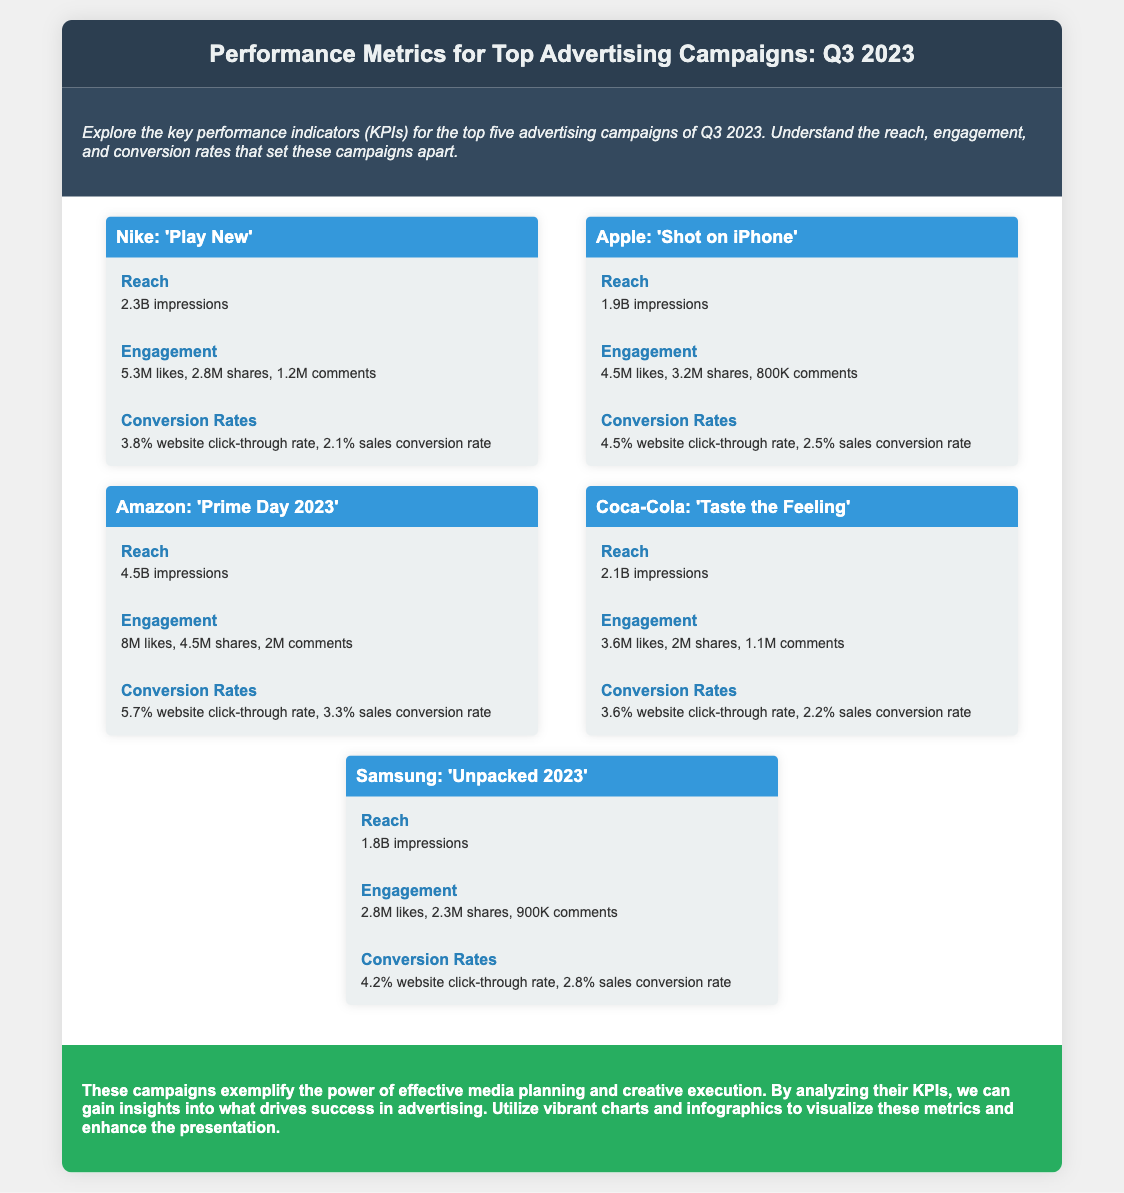What is the reach of Nike's campaign? The reach is the total impressions for the Nike campaign, which is 2.3 billion.
Answer: 2.3B impressions What were the engagement numbers for Amazon's 'Prime Day 2023'? The engagement numbers include likes, shares, and comments for the Amazon campaign, which are 8 million likes, 4.5 million shares, and 2 million comments.
Answer: 8M likes, 4.5M shares, 2M comments Which campaign had the highest conversion rate? The campaign's conversion rates are compared, and the one with the highest sales conversion rate is identified, which is Amazon's 'Prime Day 2023' at 3.3%.
Answer: 3.3% How many campaigns are featured in the document? The document lists a total of five advertising campaigns analyzed for their performance metrics.
Answer: 5 What is the engagement for Apple’s campaign? The engagement for Apple’s campaign is presented with the figures for likes, shares, and comments, which are 4.5 million likes, 3.2 million shares, and 800,000 comments.
Answer: 4.5M likes, 3.2M shares, 800K comments Which campaign had a reach of 1.8 billion impressions? The document states that Samsung's 'Unpacked 2023' campaign had a reach of 1.8 billion impressions.
Answer: Samsung: 'Unpacked 2023' What is the primary focus of the document? The document aims to explore key performance indicators (KPIs) of top advertising campaigns from the last quarter, specifically analyzing reach, engagement, and conversion rates.
Answer: Performance Metrics for Top Advertising Campaigns Which company had a lower engagement: Coca-Cola or Samsung? The engagement figures for Coca-Cola's campaign show 3.6 million likes, while Samsung's campaign shows 2.8 million likes, thus indicating which had lower engagement.
Answer: Samsung What is included in the conclusion of the document? The conclusion summarizes the effectiveness of media planning and execution and encourages the visualization of KPIs through charts and infographics.
Answer: Insights into advertising success 